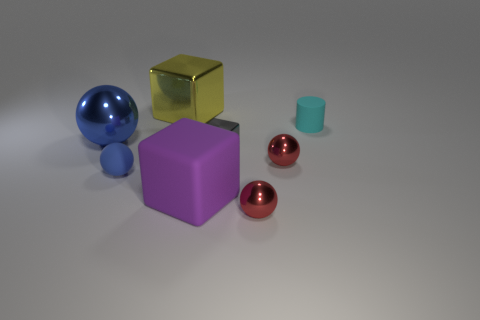There is another small thing that is the same shape as the yellow thing; what is its color?
Offer a terse response. Gray. Does the large metallic sphere have the same color as the rubber object that is to the left of the large metal block?
Offer a very short reply. Yes. The matte thing that is behind the big matte object and left of the small cyan cylinder has what shape?
Keep it short and to the point. Sphere. Are there fewer tiny cyan cylinders than large cyan cylinders?
Offer a very short reply. No. Is there a green block?
Your response must be concise. No. How many other objects are the same size as the purple matte object?
Keep it short and to the point. 2. Are the yellow thing and the big purple object that is in front of the cyan cylinder made of the same material?
Your answer should be very brief. No. Are there the same number of cyan objects in front of the cyan matte cylinder and cyan objects that are behind the blue shiny object?
Make the answer very short. No. What material is the cyan cylinder?
Give a very brief answer. Rubber. The block that is the same size as the yellow metallic object is what color?
Your answer should be very brief. Purple. 